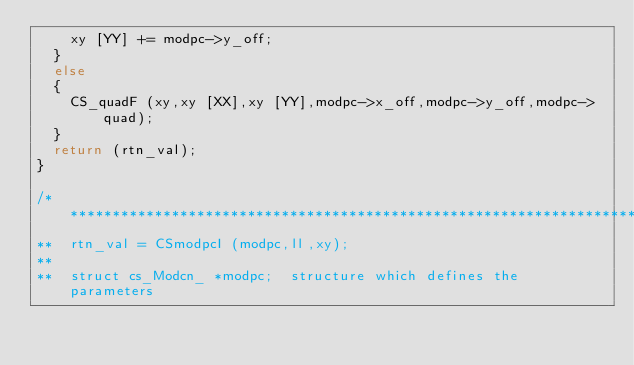Convert code to text. <code><loc_0><loc_0><loc_500><loc_500><_C_>		xy [YY] += modpc->y_off;
	}
	else
	{
		CS_quadF (xy,xy [XX],xy [YY],modpc->x_off,modpc->y_off,modpc->quad);
	}
	return (rtn_val);
}

/**********************************************************************
**	rtn_val = CSmodpcI (modpc,ll,xy);
**
**	struct cs_Modcn_ *modpc;	structure which defines the parameters</code> 